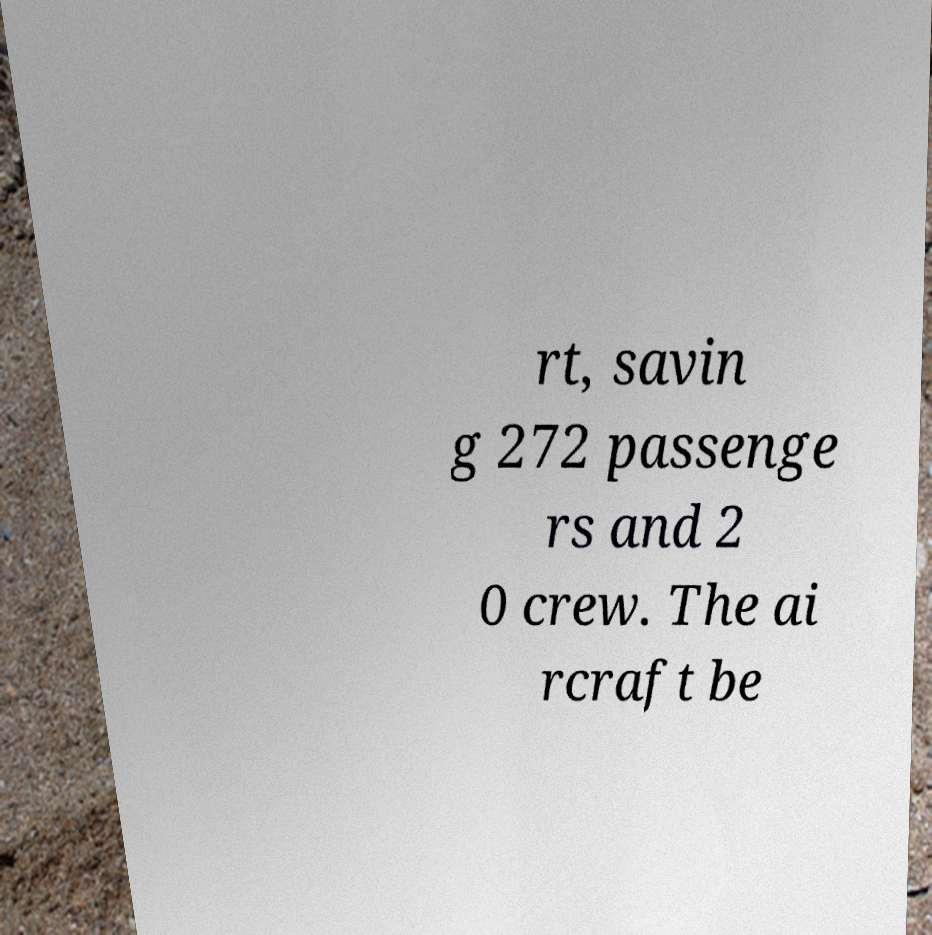I need the written content from this picture converted into text. Can you do that? rt, savin g 272 passenge rs and 2 0 crew. The ai rcraft be 